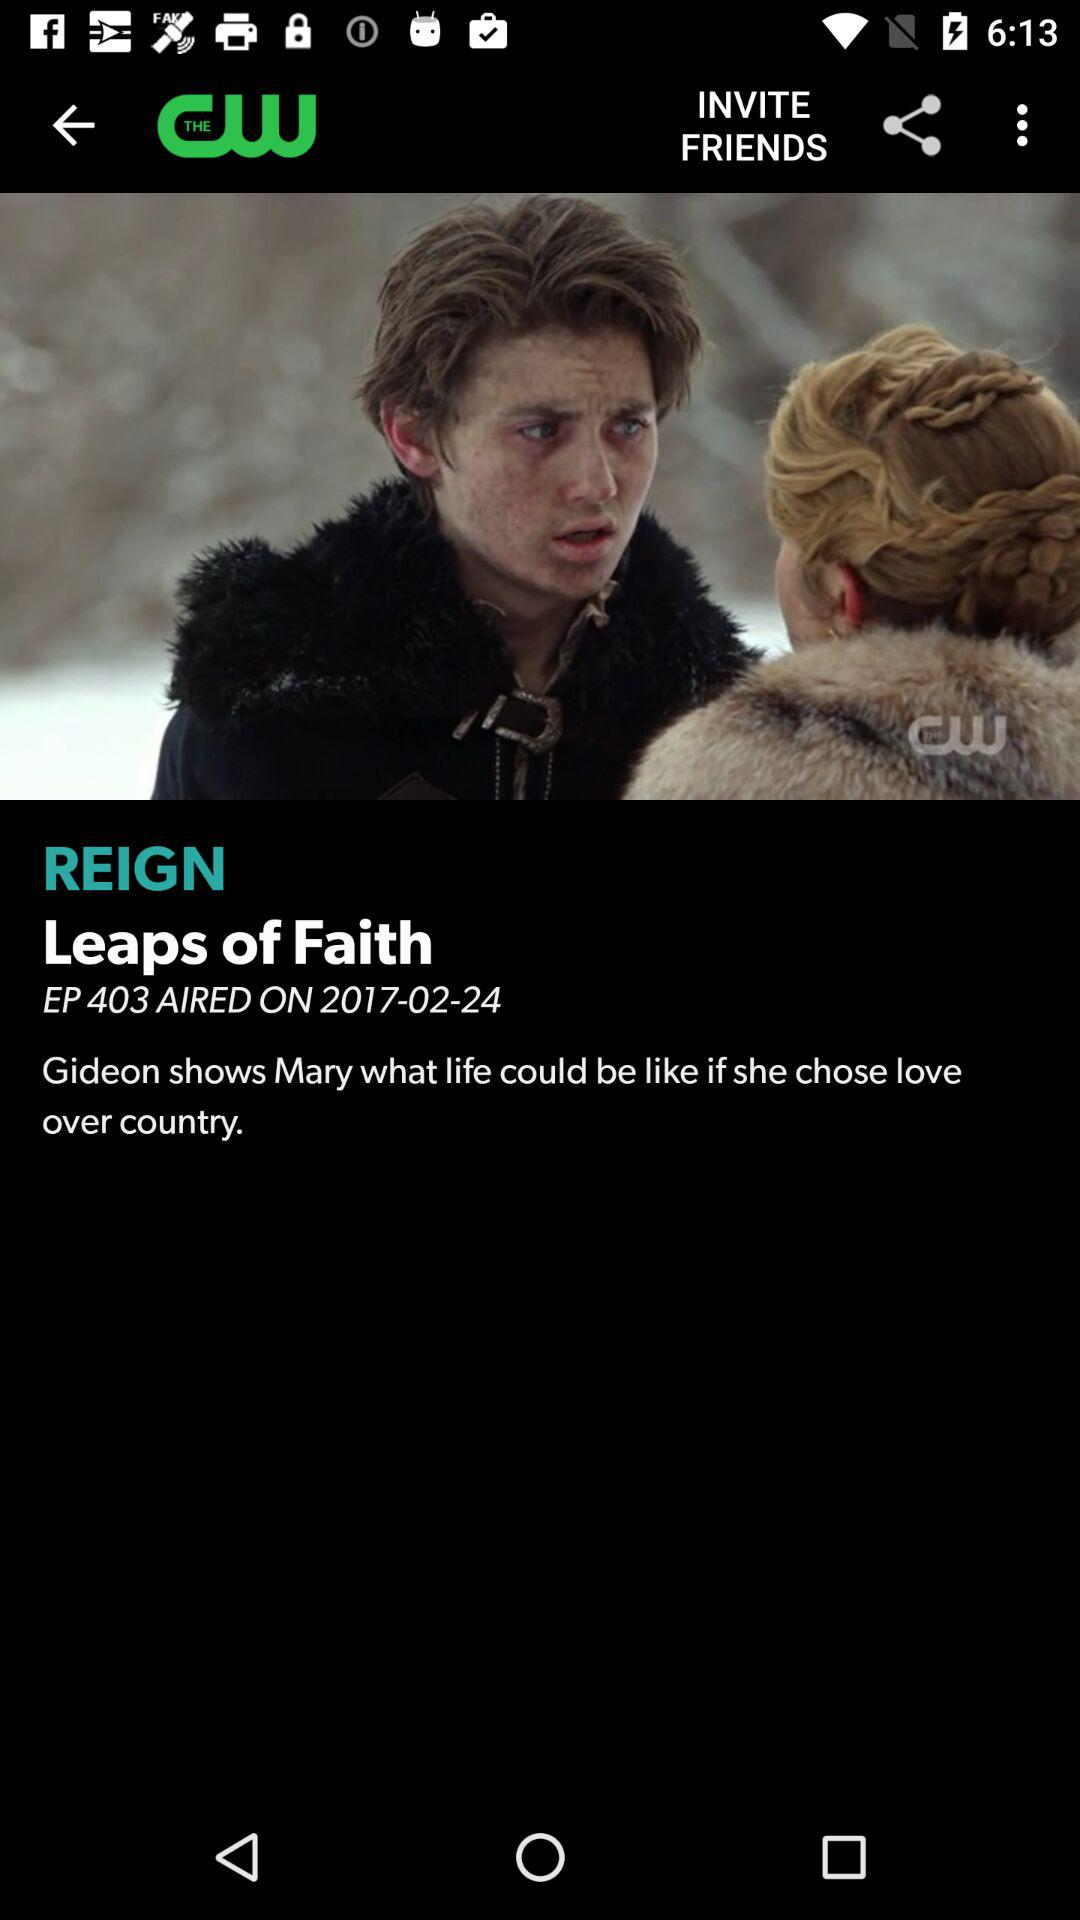What episode is airing? The episode that is airing is "Leaps of Faith". 